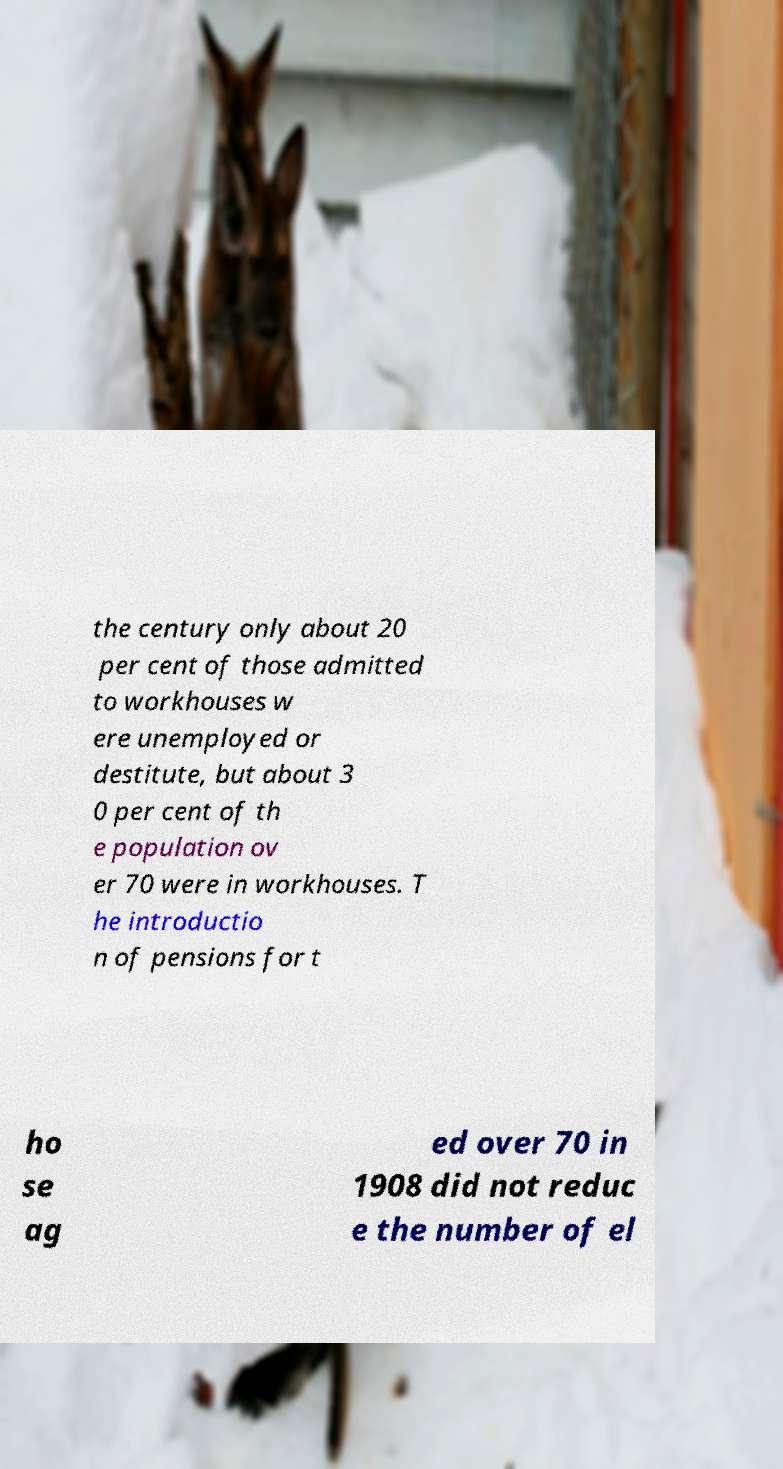Can you read and provide the text displayed in the image?This photo seems to have some interesting text. Can you extract and type it out for me? the century only about 20 per cent of those admitted to workhouses w ere unemployed or destitute, but about 3 0 per cent of th e population ov er 70 were in workhouses. T he introductio n of pensions for t ho se ag ed over 70 in 1908 did not reduc e the number of el 